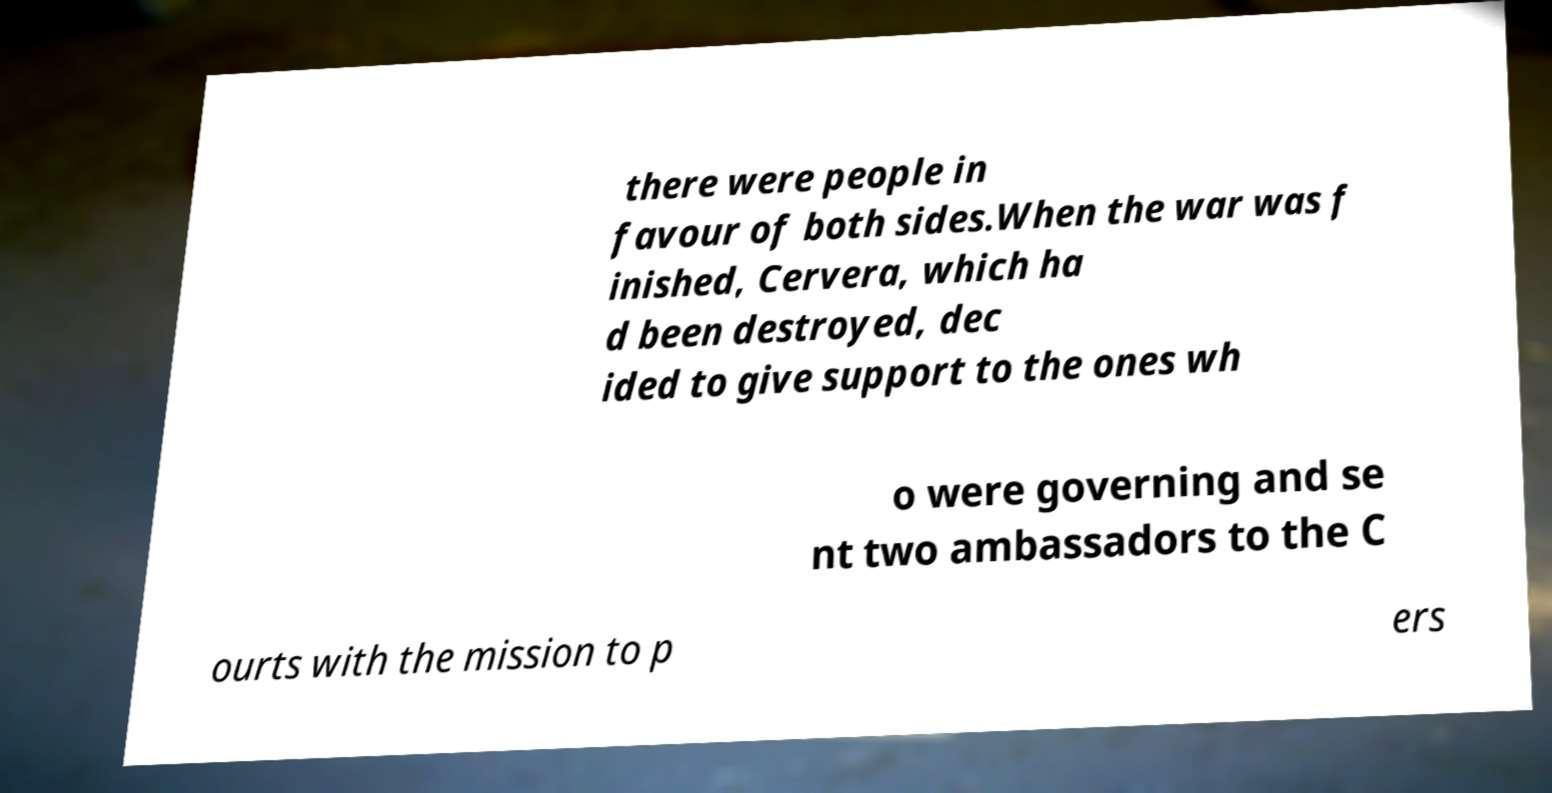Please identify and transcribe the text found in this image. there were people in favour of both sides.When the war was f inished, Cervera, which ha d been destroyed, dec ided to give support to the ones wh o were governing and se nt two ambassadors to the C ourts with the mission to p ers 